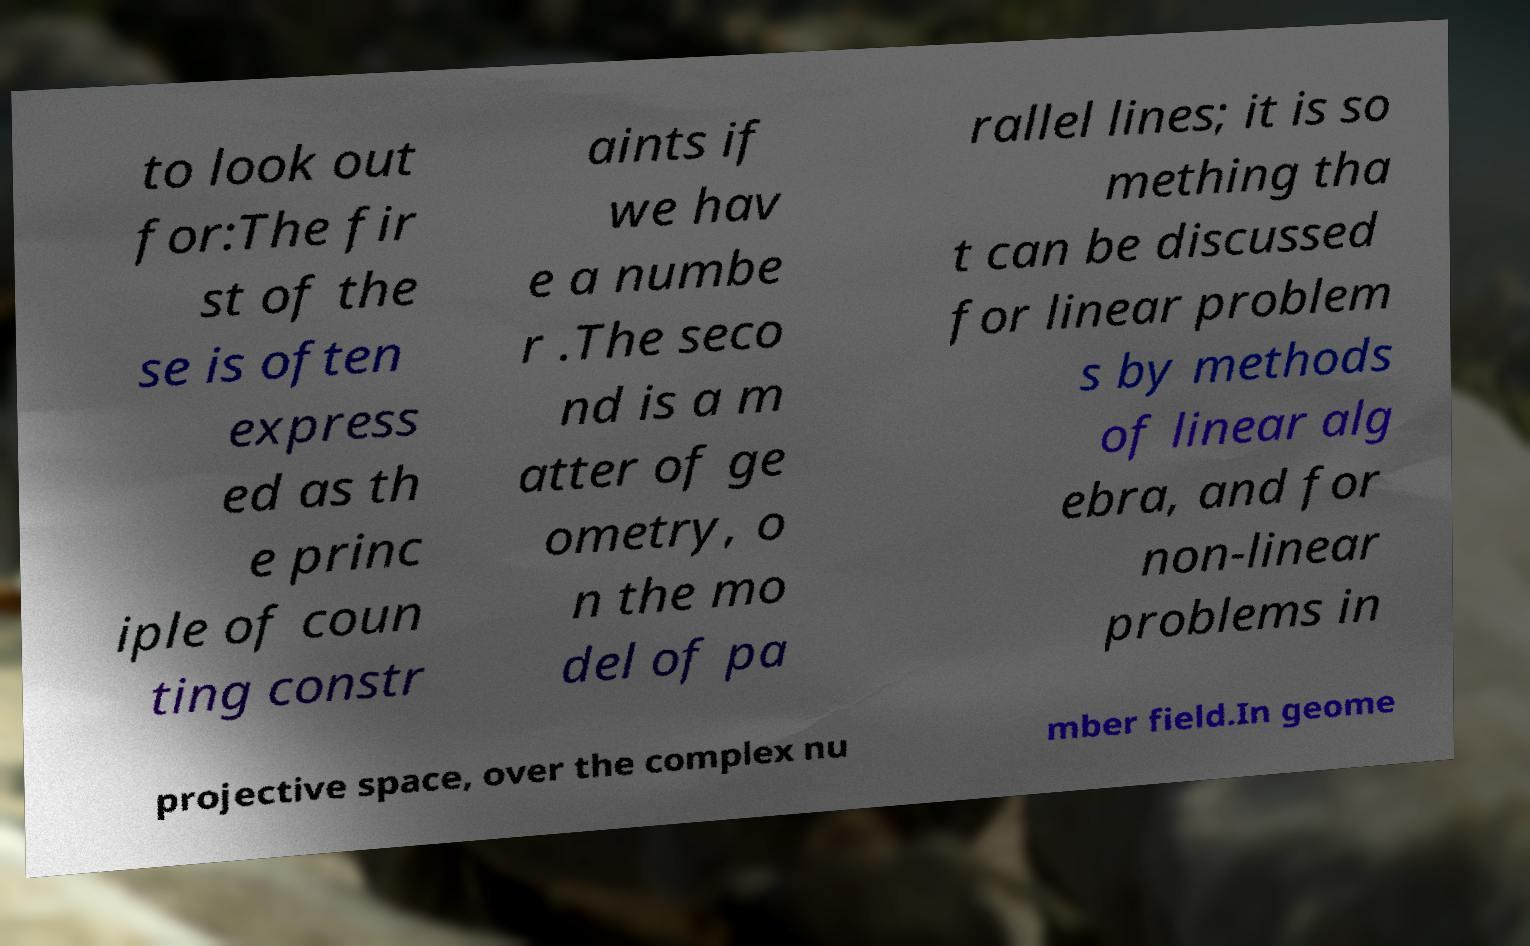Please identify and transcribe the text found in this image. to look out for:The fir st of the se is often express ed as th e princ iple of coun ting constr aints if we hav e a numbe r .The seco nd is a m atter of ge ometry, o n the mo del of pa rallel lines; it is so mething tha t can be discussed for linear problem s by methods of linear alg ebra, and for non-linear problems in projective space, over the complex nu mber field.In geome 